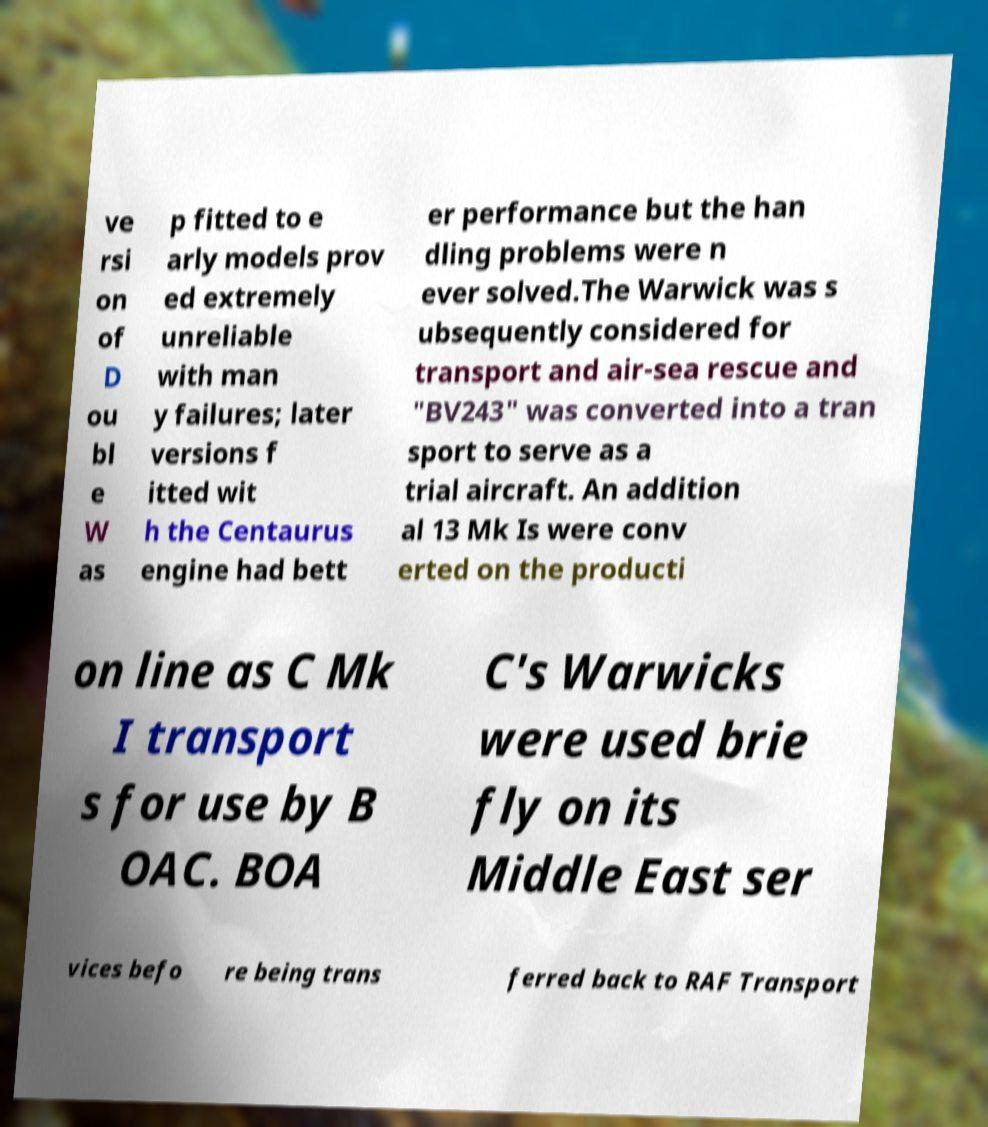Can you read and provide the text displayed in the image?This photo seems to have some interesting text. Can you extract and type it out for me? ve rsi on of D ou bl e W as p fitted to e arly models prov ed extremely unreliable with man y failures; later versions f itted wit h the Centaurus engine had bett er performance but the han dling problems were n ever solved.The Warwick was s ubsequently considered for transport and air-sea rescue and "BV243" was converted into a tran sport to serve as a trial aircraft. An addition al 13 Mk Is were conv erted on the producti on line as C Mk I transport s for use by B OAC. BOA C's Warwicks were used brie fly on its Middle East ser vices befo re being trans ferred back to RAF Transport 